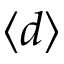<formula> <loc_0><loc_0><loc_500><loc_500>\langle d \rangle</formula> 